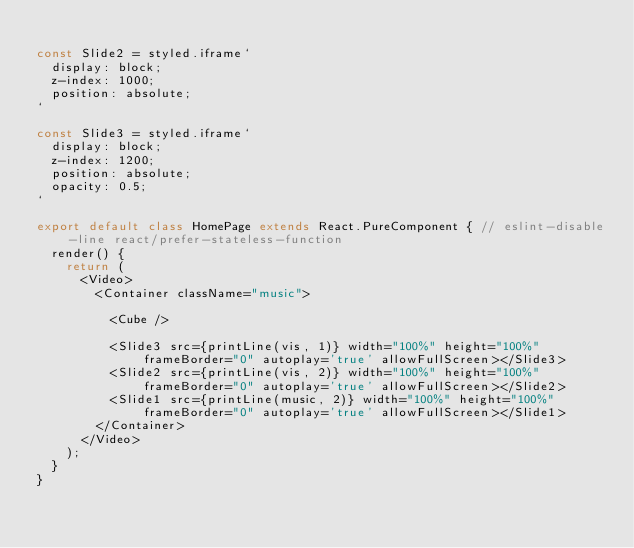Convert code to text. <code><loc_0><loc_0><loc_500><loc_500><_JavaScript_>
const Slide2 = styled.iframe`
  display: block;
  z-index: 1000;
  position: absolute;
`

const Slide3 = styled.iframe`
  display: block;
  z-index: 1200;
  position: absolute;
  opacity: 0.5;
`

export default class HomePage extends React.PureComponent { // eslint-disable-line react/prefer-stateless-function
  render() {
    return (
      <Video>
        <Container className="music">

          <Cube />

          <Slide3 src={printLine(vis, 1)} width="100%" height="100%" frameBorder="0" autoplay='true' allowFullScreen></Slide3>
          <Slide2 src={printLine(vis, 2)} width="100%" height="100%" frameBorder="0" autoplay='true' allowFullScreen></Slide2>
          <Slide1 src={printLine(music, 2)} width="100%" height="100%" frameBorder="0" autoplay='true' allowFullScreen></Slide1>
        </Container>
      </Video>
    );
  }
}
</code> 